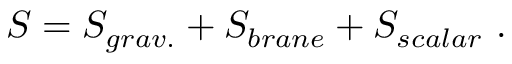Convert formula to latex. <formula><loc_0><loc_0><loc_500><loc_500>S = S _ { g r a v . } + S _ { b r a n e } + S _ { s c a l a r } \ .</formula> 